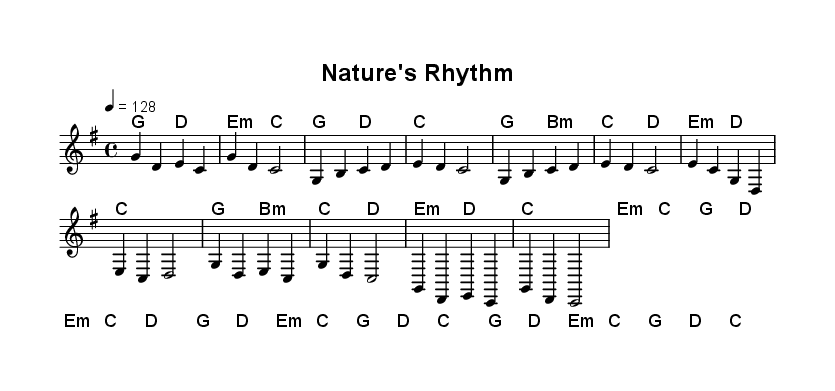What is the key signature of this music? The key signature can be identified at the beginning of the staff, which shows a G major key signature with one sharp.
Answer: G major What is the time signature of this piece? The time signature appears at the beginning of the music, displayed as a 4 over 4, which indicates four beats per measure.
Answer: 4/4 What is the tempo marking for this piece? The tempo is indicated at the start with "4 = 128," suggesting the speed of quarter notes is 128 beats per minute.
Answer: 128 How many measures are in the chorus section? By counting the measures in the chorus portion of the notation, we see two sections, each containing four measures, totaling eight measures.
Answer: 8 Describe the structure of the piece in terms of sections. The piece consists of an Intro, Verse, Pre-Chorus, and Chorus, including specific melodic and harmonic progressions for each section, clearly labeled in the sheet music.
Answer: Intro, Verse, Pre-Chorus, Chorus What type of chord is used in the first measure? The first measure shows a G major chord, which can be determined by its root note (G) and supporting notes present in the harmony.
Answer: G major 